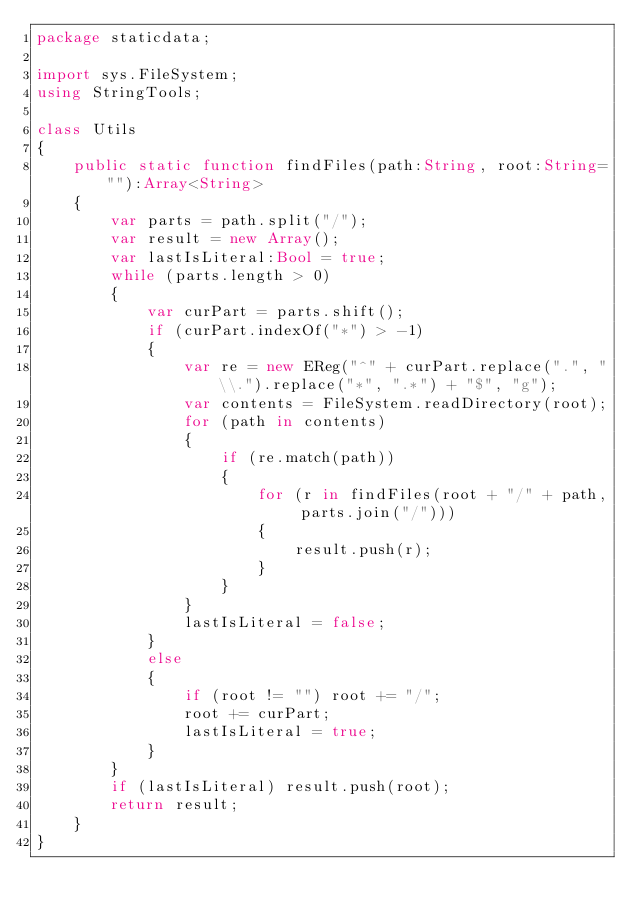Convert code to text. <code><loc_0><loc_0><loc_500><loc_500><_Haxe_>package staticdata;

import sys.FileSystem;
using StringTools;

class Utils
{
	public static function findFiles(path:String, root:String=""):Array<String>
	{
		var parts = path.split("/");
		var result = new Array();
		var lastIsLiteral:Bool = true;
		while (parts.length > 0)
		{
			var curPart = parts.shift();
			if (curPart.indexOf("*") > -1)
			{
				var re = new EReg("^" + curPart.replace(".", "\\.").replace("*", ".*") + "$", "g");
				var contents = FileSystem.readDirectory(root);
				for (path in contents)
				{
					if (re.match(path))
					{
						for (r in findFiles(root + "/" + path, parts.join("/")))
						{
							result.push(r);
						}
					}
				}
				lastIsLiteral = false;
			}
			else
			{
				if (root != "") root += "/";
				root += curPart;
				lastIsLiteral = true;
			}
		}
		if (lastIsLiteral) result.push(root);
		return result;
	}
}
</code> 